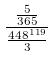Convert formula to latex. <formula><loc_0><loc_0><loc_500><loc_500>\frac { \frac { 5 } { 3 6 5 } } { \frac { 4 4 8 ^ { 1 1 9 } } { 3 } }</formula> 